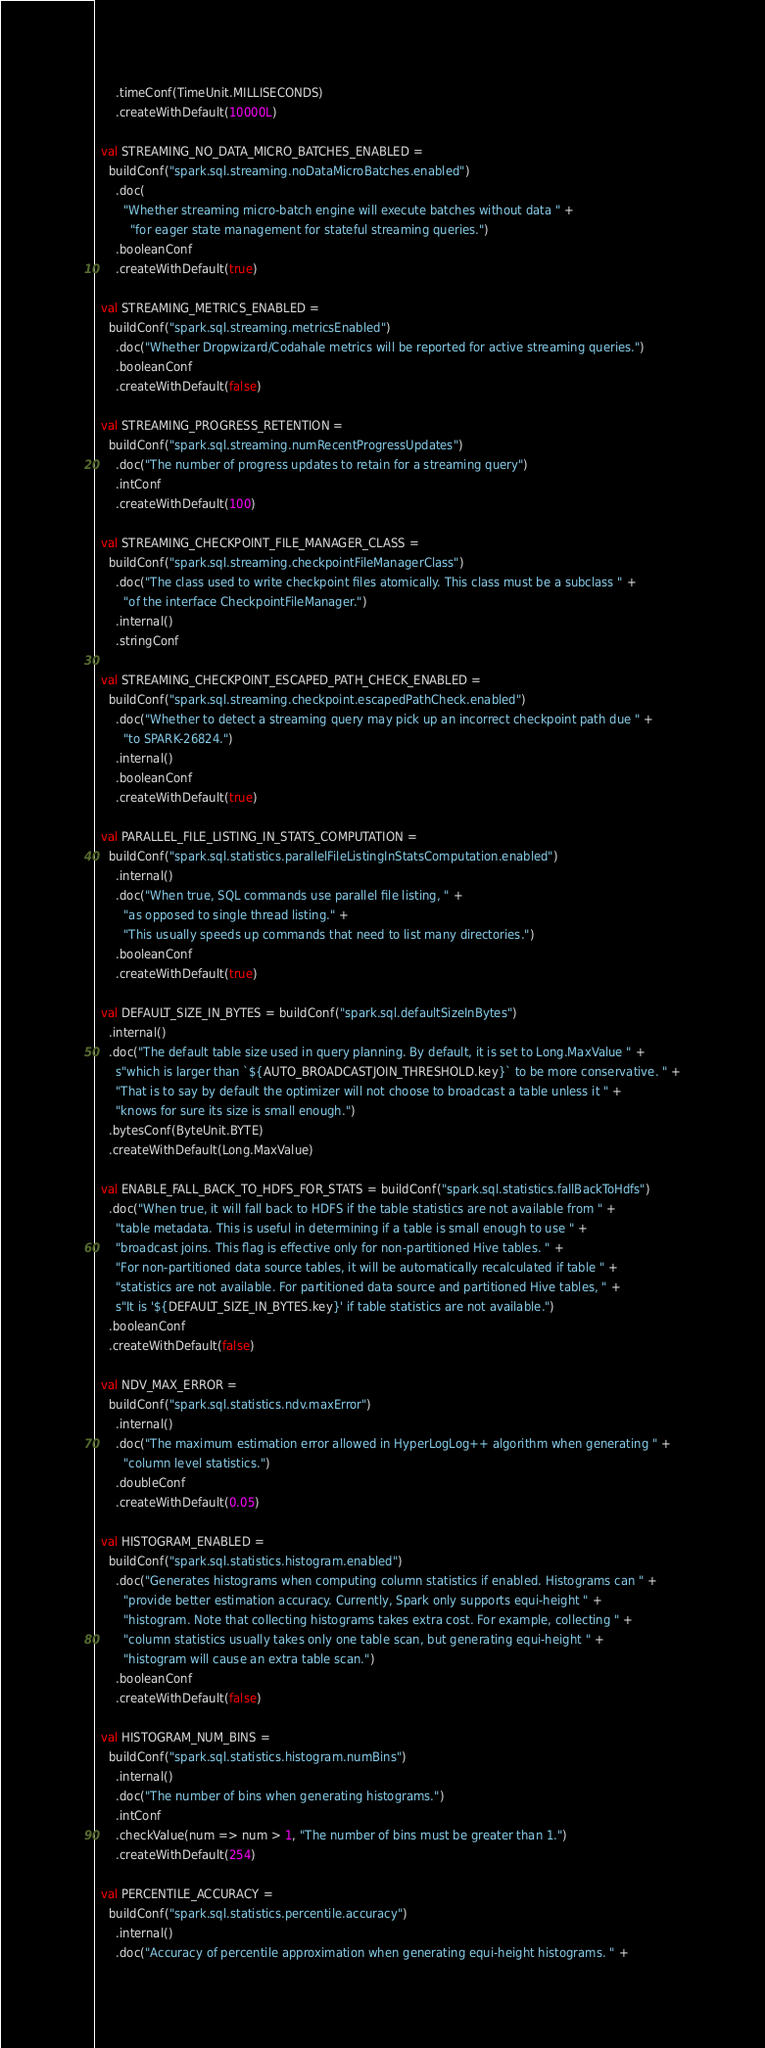Convert code to text. <code><loc_0><loc_0><loc_500><loc_500><_Scala_>      .timeConf(TimeUnit.MILLISECONDS)
      .createWithDefault(10000L)

  val STREAMING_NO_DATA_MICRO_BATCHES_ENABLED =
    buildConf("spark.sql.streaming.noDataMicroBatches.enabled")
      .doc(
        "Whether streaming micro-batch engine will execute batches without data " +
          "for eager state management for stateful streaming queries.")
      .booleanConf
      .createWithDefault(true)

  val STREAMING_METRICS_ENABLED =
    buildConf("spark.sql.streaming.metricsEnabled")
      .doc("Whether Dropwizard/Codahale metrics will be reported for active streaming queries.")
      .booleanConf
      .createWithDefault(false)

  val STREAMING_PROGRESS_RETENTION =
    buildConf("spark.sql.streaming.numRecentProgressUpdates")
      .doc("The number of progress updates to retain for a streaming query")
      .intConf
      .createWithDefault(100)

  val STREAMING_CHECKPOINT_FILE_MANAGER_CLASS =
    buildConf("spark.sql.streaming.checkpointFileManagerClass")
      .doc("The class used to write checkpoint files atomically. This class must be a subclass " +
        "of the interface CheckpointFileManager.")
      .internal()
      .stringConf

  val STREAMING_CHECKPOINT_ESCAPED_PATH_CHECK_ENABLED =
    buildConf("spark.sql.streaming.checkpoint.escapedPathCheck.enabled")
      .doc("Whether to detect a streaming query may pick up an incorrect checkpoint path due " +
        "to SPARK-26824.")
      .internal()
      .booleanConf
      .createWithDefault(true)

  val PARALLEL_FILE_LISTING_IN_STATS_COMPUTATION =
    buildConf("spark.sql.statistics.parallelFileListingInStatsComputation.enabled")
      .internal()
      .doc("When true, SQL commands use parallel file listing, " +
        "as opposed to single thread listing." +
        "This usually speeds up commands that need to list many directories.")
      .booleanConf
      .createWithDefault(true)

  val DEFAULT_SIZE_IN_BYTES = buildConf("spark.sql.defaultSizeInBytes")
    .internal()
    .doc("The default table size used in query planning. By default, it is set to Long.MaxValue " +
      s"which is larger than `${AUTO_BROADCASTJOIN_THRESHOLD.key}` to be more conservative. " +
      "That is to say by default the optimizer will not choose to broadcast a table unless it " +
      "knows for sure its size is small enough.")
    .bytesConf(ByteUnit.BYTE)
    .createWithDefault(Long.MaxValue)

  val ENABLE_FALL_BACK_TO_HDFS_FOR_STATS = buildConf("spark.sql.statistics.fallBackToHdfs")
    .doc("When true, it will fall back to HDFS if the table statistics are not available from " +
      "table metadata. This is useful in determining if a table is small enough to use " +
      "broadcast joins. This flag is effective only for non-partitioned Hive tables. " +
      "For non-partitioned data source tables, it will be automatically recalculated if table " +
      "statistics are not available. For partitioned data source and partitioned Hive tables, " +
      s"It is '${DEFAULT_SIZE_IN_BYTES.key}' if table statistics are not available.")
    .booleanConf
    .createWithDefault(false)

  val NDV_MAX_ERROR =
    buildConf("spark.sql.statistics.ndv.maxError")
      .internal()
      .doc("The maximum estimation error allowed in HyperLogLog++ algorithm when generating " +
        "column level statistics.")
      .doubleConf
      .createWithDefault(0.05)

  val HISTOGRAM_ENABLED =
    buildConf("spark.sql.statistics.histogram.enabled")
      .doc("Generates histograms when computing column statistics if enabled. Histograms can " +
        "provide better estimation accuracy. Currently, Spark only supports equi-height " +
        "histogram. Note that collecting histograms takes extra cost. For example, collecting " +
        "column statistics usually takes only one table scan, but generating equi-height " +
        "histogram will cause an extra table scan.")
      .booleanConf
      .createWithDefault(false)

  val HISTOGRAM_NUM_BINS =
    buildConf("spark.sql.statistics.histogram.numBins")
      .internal()
      .doc("The number of bins when generating histograms.")
      .intConf
      .checkValue(num => num > 1, "The number of bins must be greater than 1.")
      .createWithDefault(254)

  val PERCENTILE_ACCURACY =
    buildConf("spark.sql.statistics.percentile.accuracy")
      .internal()
      .doc("Accuracy of percentile approximation when generating equi-height histograms. " +</code> 